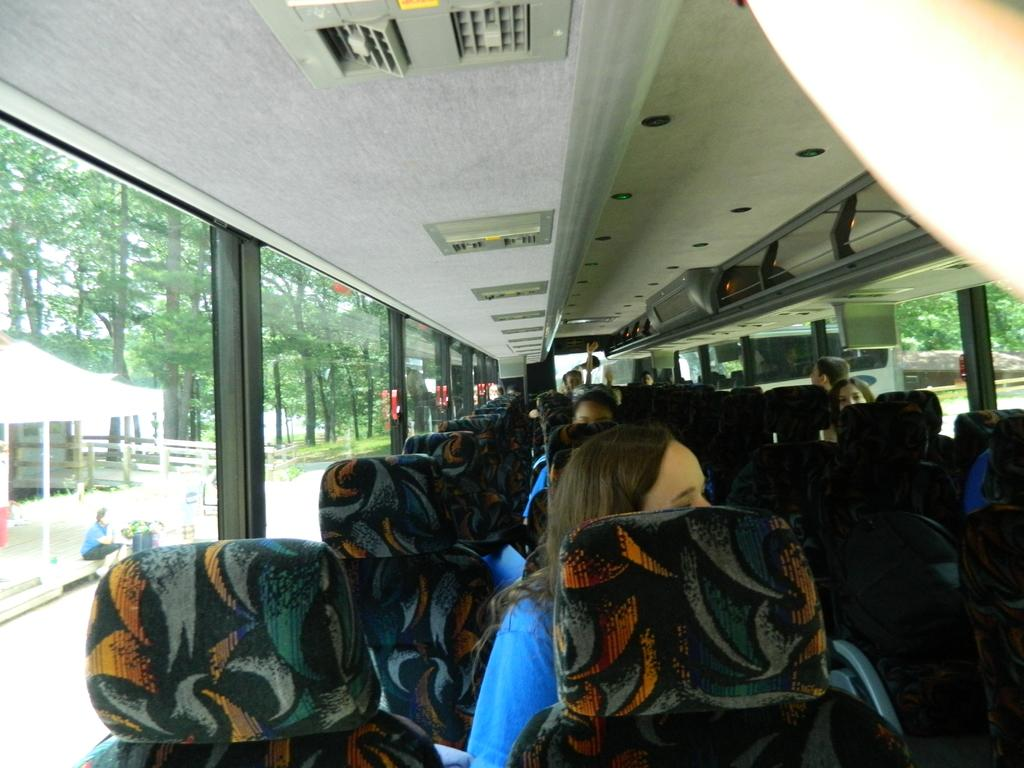What type of vehicle is depicted in the image? The image appears to be an inner view of a bus. What can be found inside the bus? There are seats in the bus. Are there any passengers in the bus? Yes, there are people seated in the bus. What is the design of the bus windows? The bus has glass windows. What can be seen outside the bus through the windows? A house and trees are visible through the bus window. Where is the person seated in relation to the window? There is a human seated near the window. What type of toothbrush is being used by the person seated near the window? There is no toothbrush present in the image; it is an interior view of a bus with people seated inside. What is the person smashing through the window in the image? There is no person smashing through the window in the image; the bus has glass windows with a view of a house and trees outside. 